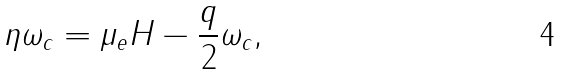<formula> <loc_0><loc_0><loc_500><loc_500>\eta \omega _ { c } = \mu _ { e } H - \frac { q } { 2 } \omega _ { c } ,</formula> 